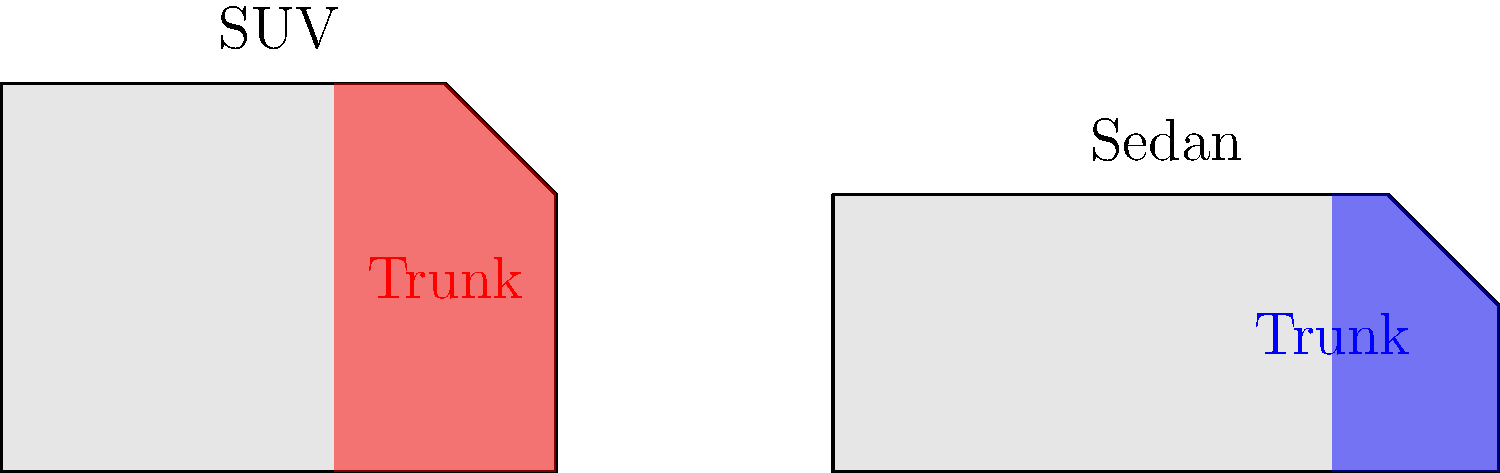Based on the 2D silhouettes of an SUV and a sedan shown above, which vehicle type typically offers more cargo space? To determine which vehicle type typically offers more cargo space, we need to analyze the highlighted trunk areas in the given silhouettes:

1. SUV (left silhouette):
   - The trunk area (highlighted in red) extends from the rear of the vehicle to almost the middle.
   - It occupies a significant portion of the vehicle's total area.
   - The trunk space is taller, utilizing the full height of the vehicle.

2. Sedan (right silhouette):
   - The trunk area (highlighted in blue) is limited to the rear portion of the vehicle.
   - It occupies a smaller percentage of the vehicle's total area compared to the SUV.
   - The trunk space is shorter in height, confined to the area below the rear window.

3. Comparison:
   - The SUV's trunk area appears larger in both width and height.
   - The SUV's cargo space extends higher, allowing for taller items to be stored.
   - The sedan's trunk is more limited in size and shape.

4. General design characteristics:
   - SUVs are designed with a focus on utility and cargo capacity.
   - Sedans prioritize passenger comfort and aerodynamics, often at the expense of cargo space.

Based on these observations and general vehicle design principles, SUVs typically offer more cargo space than sedans.
Answer: SUV 